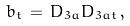<formula> <loc_0><loc_0><loc_500><loc_500>b _ { t } \, = \, D _ { 3 a } D _ { 3 a t } \, ,</formula> 